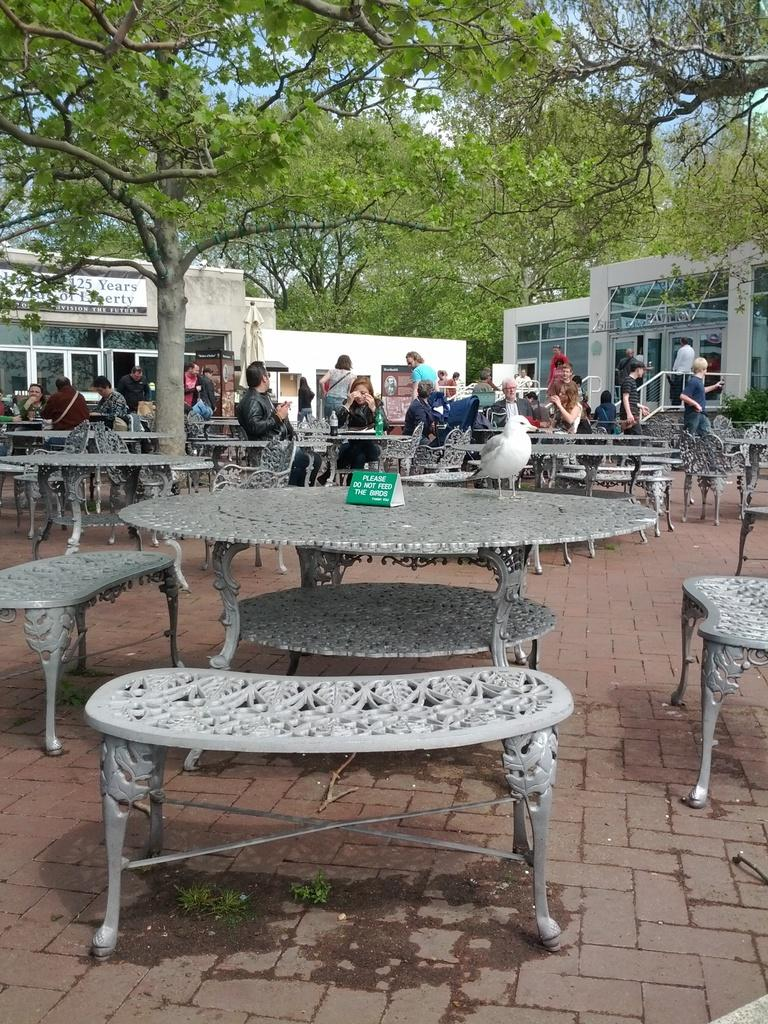What are the people in the image doing? The persons in the image are sitting on benches. What is present in the image besides the people? There is a table in the image. What can be seen in the background of the image? There are buildings and trees in the background of the image. What type of bear can be seen interacting with the persons sitting on benches in the image? There is no bear present in the image; it only features persons sitting on benches, a table, and the background with buildings and trees. 